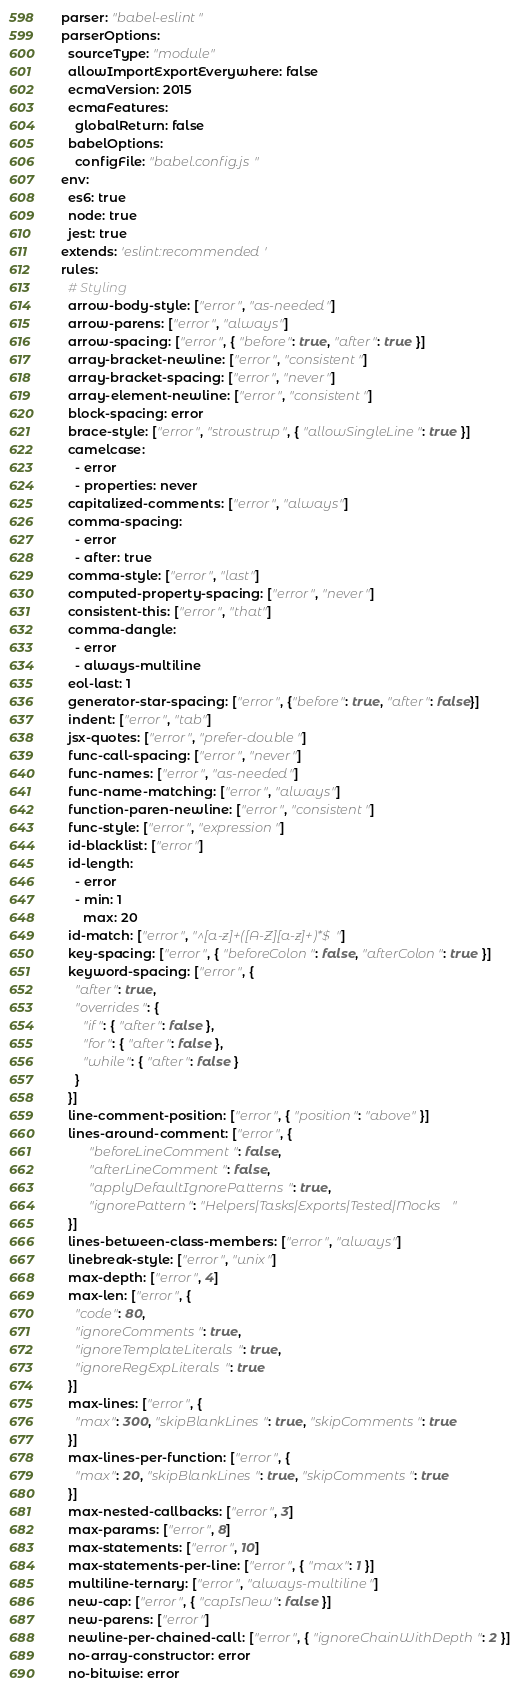<code> <loc_0><loc_0><loc_500><loc_500><_YAML_>parser: "babel-eslint"
parserOptions:
  sourceType: "module"
  allowImportExportEverywhere: false
  ecmaVersion: 2015
  ecmaFeatures:
    globalReturn: false
  babelOptions:
    configFile: "babel.config.js"
env:
  es6: true
  node: true
  jest: true
extends: 'eslint:recommended'
rules:
  # Styling
  arrow-body-style: ["error", "as-needed"]
  arrow-parens: ["error", "always"]
  arrow-spacing: ["error", { "before": true, "after": true }]
  array-bracket-newline: ["error", "consistent"]
  array-bracket-spacing: ["error", "never"]
  array-element-newline: ["error", "consistent"]
  block-spacing: error
  brace-style: ["error", "stroustrup", { "allowSingleLine": true }]
  camelcase:
    - error
    - properties: never
  capitalized-comments: ["error", "always"]
  comma-spacing:
    - error
    - after: true
  comma-style: ["error", "last"]
  computed-property-spacing: ["error", "never"]
  consistent-this: ["error", "that"]
  comma-dangle:
    - error
    - always-multiline
  eol-last: 1
  generator-star-spacing: ["error", {"before": true, "after": false}]
  indent: ["error", "tab"]
  jsx-quotes: ["error", "prefer-double"]
  func-call-spacing: ["error", "never"]
  func-names: ["error", "as-needed"]
  func-name-matching: ["error", "always"]
  function-paren-newline: ["error", "consistent"]
  func-style: ["error", "expression"]
  id-blacklist: ["error"]
  id-length:
    - error
    - min: 1
      max: 20
  id-match: ["error", "^[a-z]+([A-Z][a-z]+)*$"]
  key-spacing: ["error", { "beforeColon": false, "afterColon": true }]
  keyword-spacing: ["error", {
    "after": true,
    "overrides": {
      "if": { "after": false },
      "for": { "after": false },
      "while": { "after": false }
    }
  }]
  line-comment-position: ["error", { "position": "above" }]
  lines-around-comment: ["error", {
		"beforeLineComment": false,
		"afterLineComment": false,
		"applyDefaultIgnorePatterns": true,
		"ignorePattern": "Helpers|Tasks|Exports|Tested|Mocks"
  }]
  lines-between-class-members: ["error", "always"]
  linebreak-style: ["error", "unix"]
  max-depth: ["error", 4]
  max-len: ["error", {
    "code": 80,
    "ignoreComments": true,
    "ignoreTemplateLiterals": true,
    "ignoreRegExpLiterals": true
  }]
  max-lines: ["error", {
    "max": 300, "skipBlankLines": true, "skipComments": true
  }]
  max-lines-per-function: ["error", {
    "max": 20, "skipBlankLines": true, "skipComments": true
  }]
  max-nested-callbacks: ["error", 3]
  max-params: ["error", 8]
  max-statements: ["error", 10]
  max-statements-per-line: ["error", { "max": 1 }]
  multiline-ternary: ["error", "always-multiline"]
  new-cap: ["error", { "capIsNew": false }]
  new-parens: ["error"]
  newline-per-chained-call: ["error", { "ignoreChainWithDepth": 2 }]
  no-array-constructor: error
  no-bitwise: error</code> 